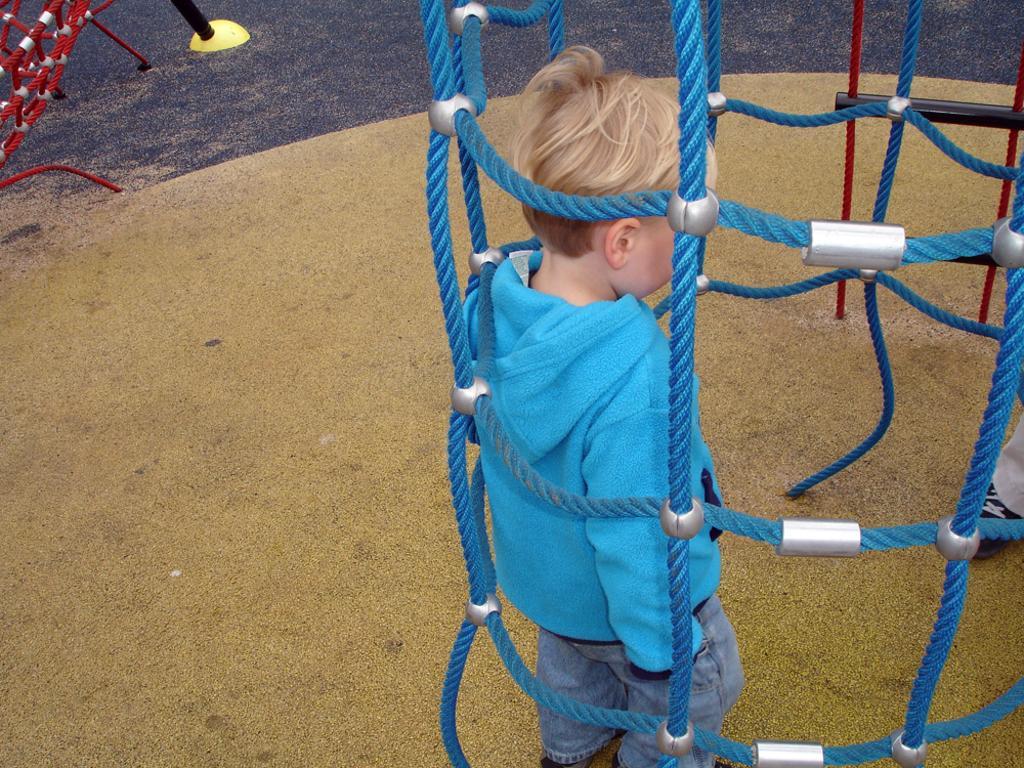How would you summarize this image in a sentence or two? In this image there is a boy standing behind the ropes. Left top there is an object on the land. 